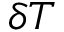<formula> <loc_0><loc_0><loc_500><loc_500>\delta T</formula> 